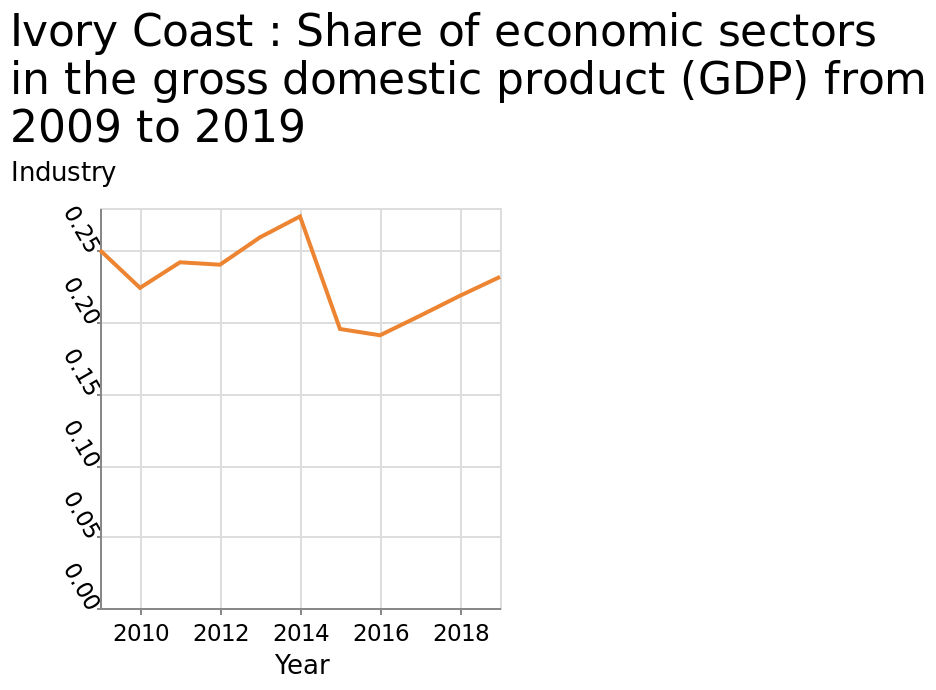<image>
When did the share of economic sectors in the gross domestic product in the Ivory Coast reach its lowest point? The share of economic sectors in the gross domestic product in the Ivory Coast reached its lowest point in 2016. 